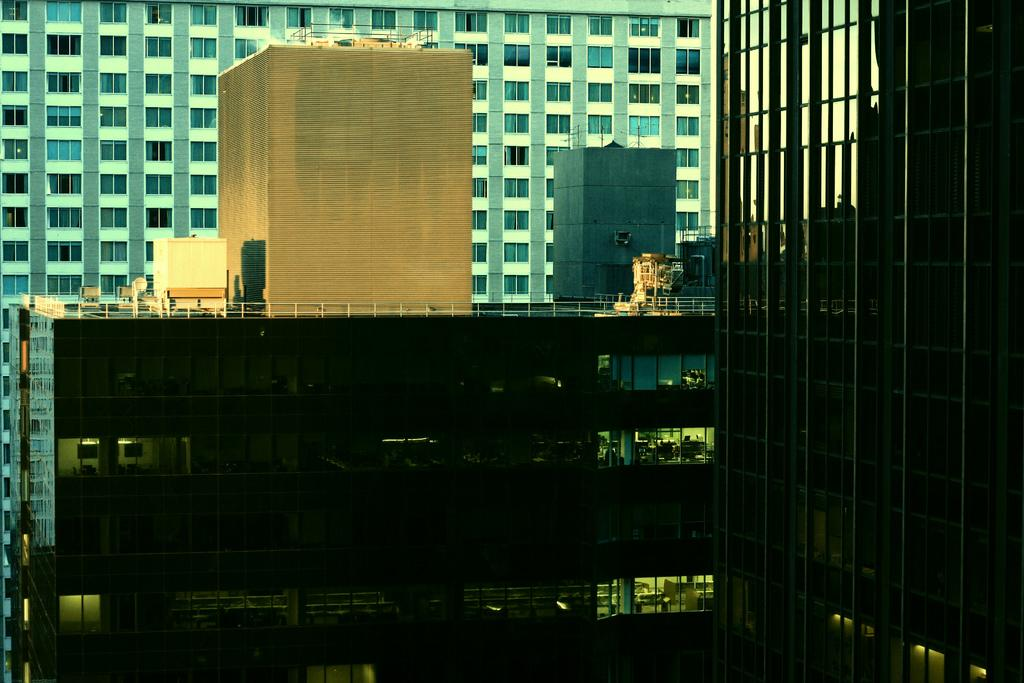What type of structures are present in the image? There are buildings in the image. What features can be observed on the buildings? The buildings have windows, railings, curtains, and lights. Can you describe any objects visible in the image? Unfortunately, the provided facts do not specify any objects visible in the image. What type of war is being fought in the image? There is no war present in the image; it features buildings with various features. What scientific discoveries are being made in the image? There is no indication of scientific research or discoveries in the image; it focuses on buildings and their features. 